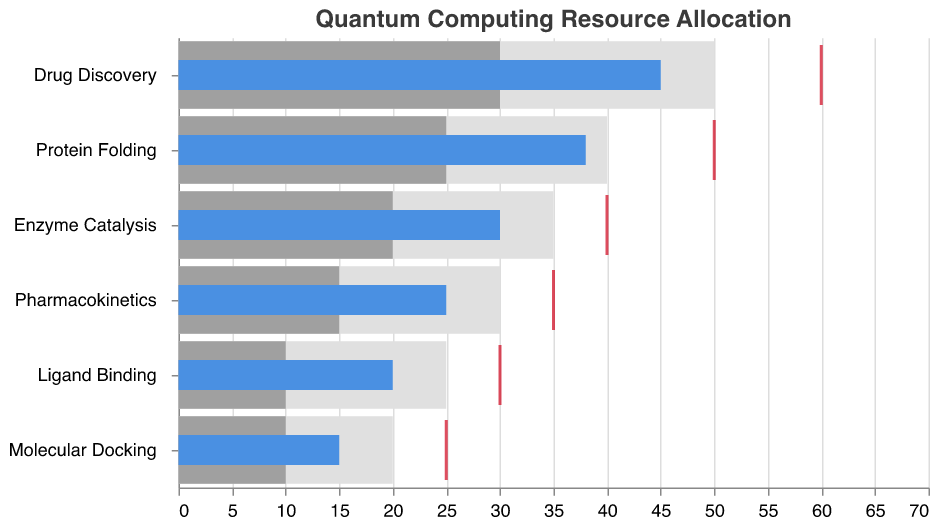What's the title of the chart? The title is displayed at the top of the chart. It is "Quantum Computing Resource Allocation".
Answer: Quantum Computing Resource Allocation What are the target resource allocations for 'Drug Discovery' and 'Ligand Binding'? The target resource allocations are indicated by red tick marks on the chart. For 'Drug Discovery', the target is 60, and for 'Ligand Binding', the target is 30.
Answer: 60 and 30 How many features (molecular simulation projects) are represented in the chart? The features are listed on the y-axis of the chart. Counting the items, there are 6 features.
Answer: 6 Which molecular simulation project has the highest actual resource allocation? The actual resource allocations are represented by the blue bars. The longest blue bar corresponds to 'Drug Discovery' with an allocation of 45.
Answer: Drug Discovery What are the three ranges used for each feature, and what do they represent? The three ranges are captured as shades of gray bars and they represent benchmarking metrics, likely tiers of resource allocation effectiveness. They range from 'Range1' (lightest grey) to 'Range3' (darkest grey).
Answer: Effectiveness benchmarks How far is 'Protein Folding' from hitting its target allocation compared to 'Molecular Docking'? 'Protein Folding' has an actual allocation of 38 and a target of 50, making it 12 units short. 'Molecular Docking' has an actual allocation of 15 and a target of 25, making it 10 units short.
Answer: 12 units for Protein Folding, 10 units for Molecular Docking Which molecular simulation projects have their actual resource allocation within the 'Range3' zone? The 'Range3' zones are the darkest grey areas. Both 'Protein Folding' at 38 (maximum of 40) and 'Drug Discovery' at 45 (maximum of 50) fall within their respective 'Range3' zones.
Answer: Drug Discovery and Protein Folding What is the actual resource allocation for 'Pharmacokinetics' and does it meet the 'Range2' benchmark? The actual resource allocation for 'Pharmacokinetics' is 25. The 'Range2' benchmark extends to 15, so it exceeds this benchmark.
Answer: 25, yes Which project has the smallest actual resource allocation and what is the value? The smallest blue bar represents 'Molecular Docking' with an actual resource allocation of 15.
Answer: Molecular Docking, 15 How many features have their actual resource allocation above their 'Range2' but below their 'Target'? There are 3 features that meet this criterion: 'Drug Discovery', 'Protein Folding', and 'Enzyme Catalysis'.
Answer: 3 